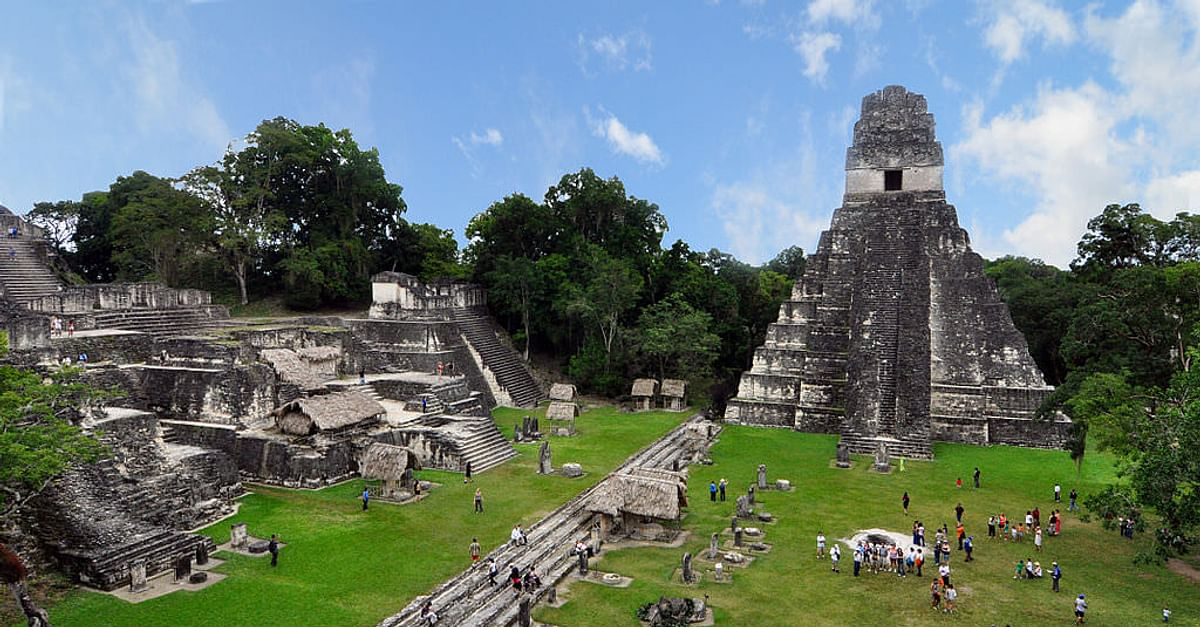What is this photo about'? The image captures the grandeur and historical significance of the Tikal temple complex, an iconic archaeological site in Guatemala. From a high vantage point, the prominent feature is a towering, pyramid-like temple with a flat top that pierces the vibrant blue sky. This central stone structure serves as a testament to the architectural prowess of the ancient Maya civilization. 

The temple is surrounded by lush greenery, with trees and vegetation enveloping the stone edifices, highlighting the harmonious coexistence of man-made and natural elements. The dense forest backdrop contrasts beautifully with the gray stones, creating a picturesque scene. 

Scattered throughout the complex are tiny figures of visitors, giving a sense of scale and emphasizing the monumental size of the temple. Their presence adds a dynamic and lively aspect to the image, showcasing the site's continued allure for travelers and history enthusiasts. 

Overall, the photograph provides a detailed and breathtaking view of the Tikal temple complex, blending historical architecture, natural beauty, and human interest into a single captivating snapshot. 